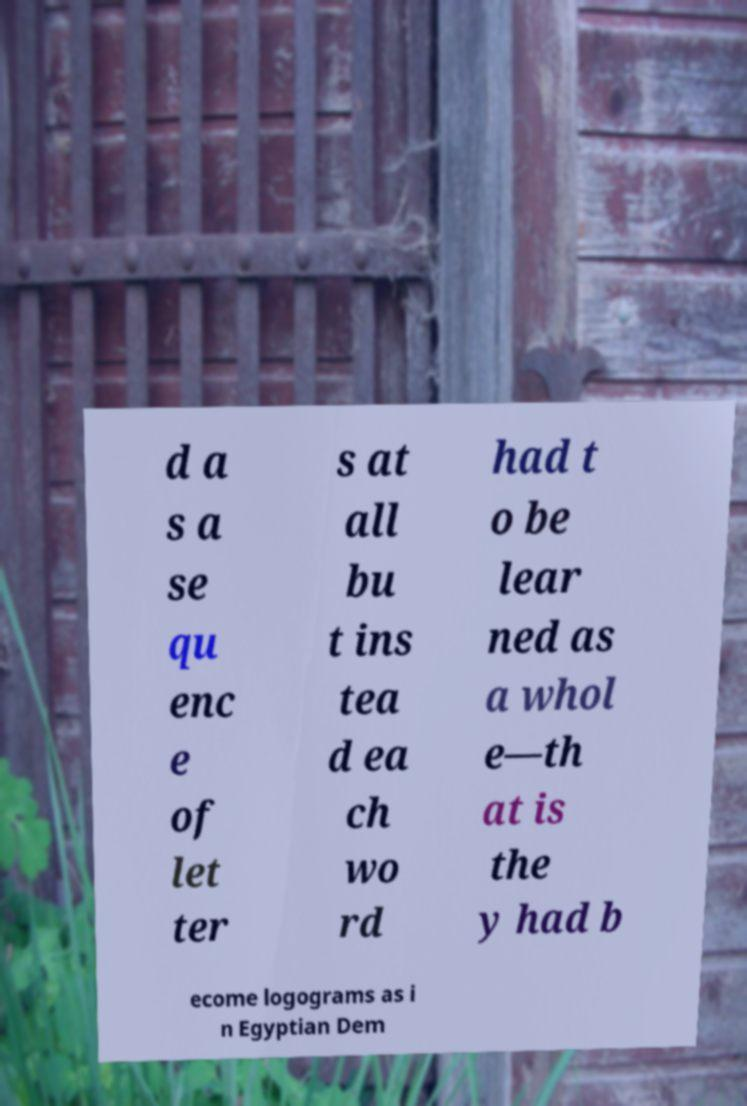Can you accurately transcribe the text from the provided image for me? d a s a se qu enc e of let ter s at all bu t ins tea d ea ch wo rd had t o be lear ned as a whol e—th at is the y had b ecome logograms as i n Egyptian Dem 